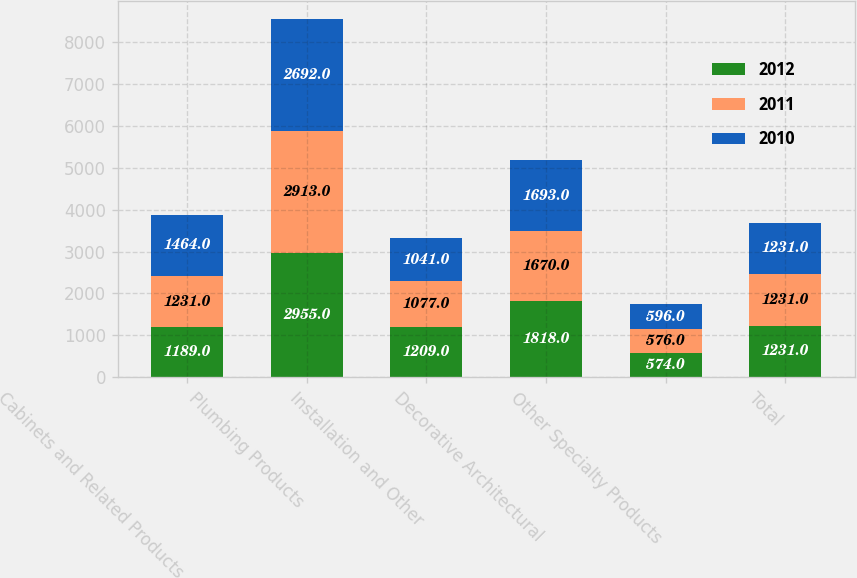Convert chart. <chart><loc_0><loc_0><loc_500><loc_500><stacked_bar_chart><ecel><fcel>Cabinets and Related Products<fcel>Plumbing Products<fcel>Installation and Other<fcel>Decorative Architectural<fcel>Other Specialty Products<fcel>Total<nl><fcel>2012<fcel>1189<fcel>2955<fcel>1209<fcel>1818<fcel>574<fcel>1231<nl><fcel>2011<fcel>1231<fcel>2913<fcel>1077<fcel>1670<fcel>576<fcel>1231<nl><fcel>2010<fcel>1464<fcel>2692<fcel>1041<fcel>1693<fcel>596<fcel>1231<nl></chart> 